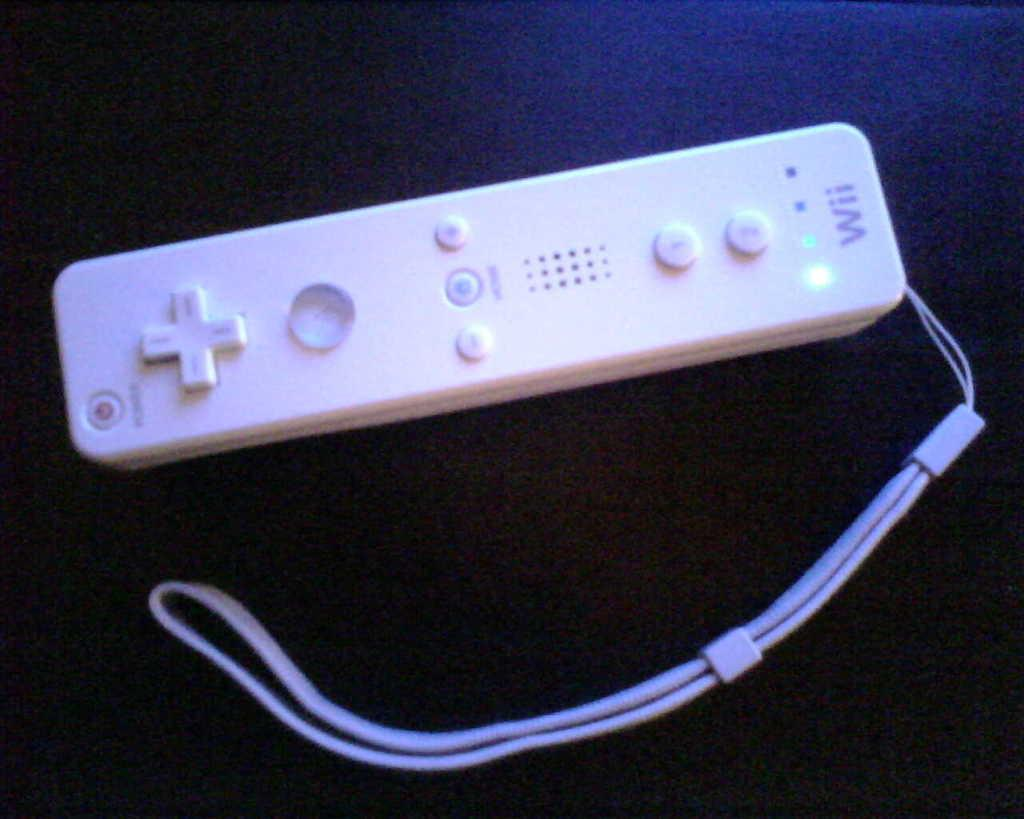<image>
Write a terse but informative summary of the picture. A white Wii controller is on the dark bluish purple background. 